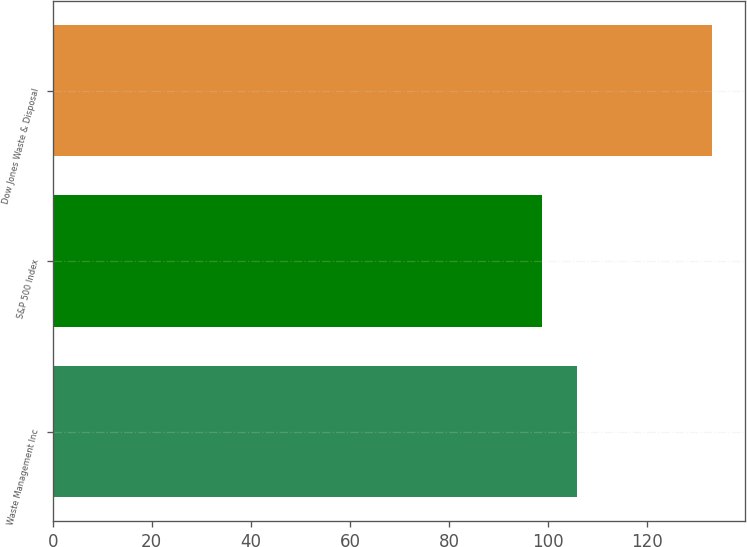<chart> <loc_0><loc_0><loc_500><loc_500><bar_chart><fcel>Waste Management Inc<fcel>S&P 500 Index<fcel>Dow Jones Waste & Disposal<nl><fcel>105.89<fcel>98.76<fcel>133.03<nl></chart> 